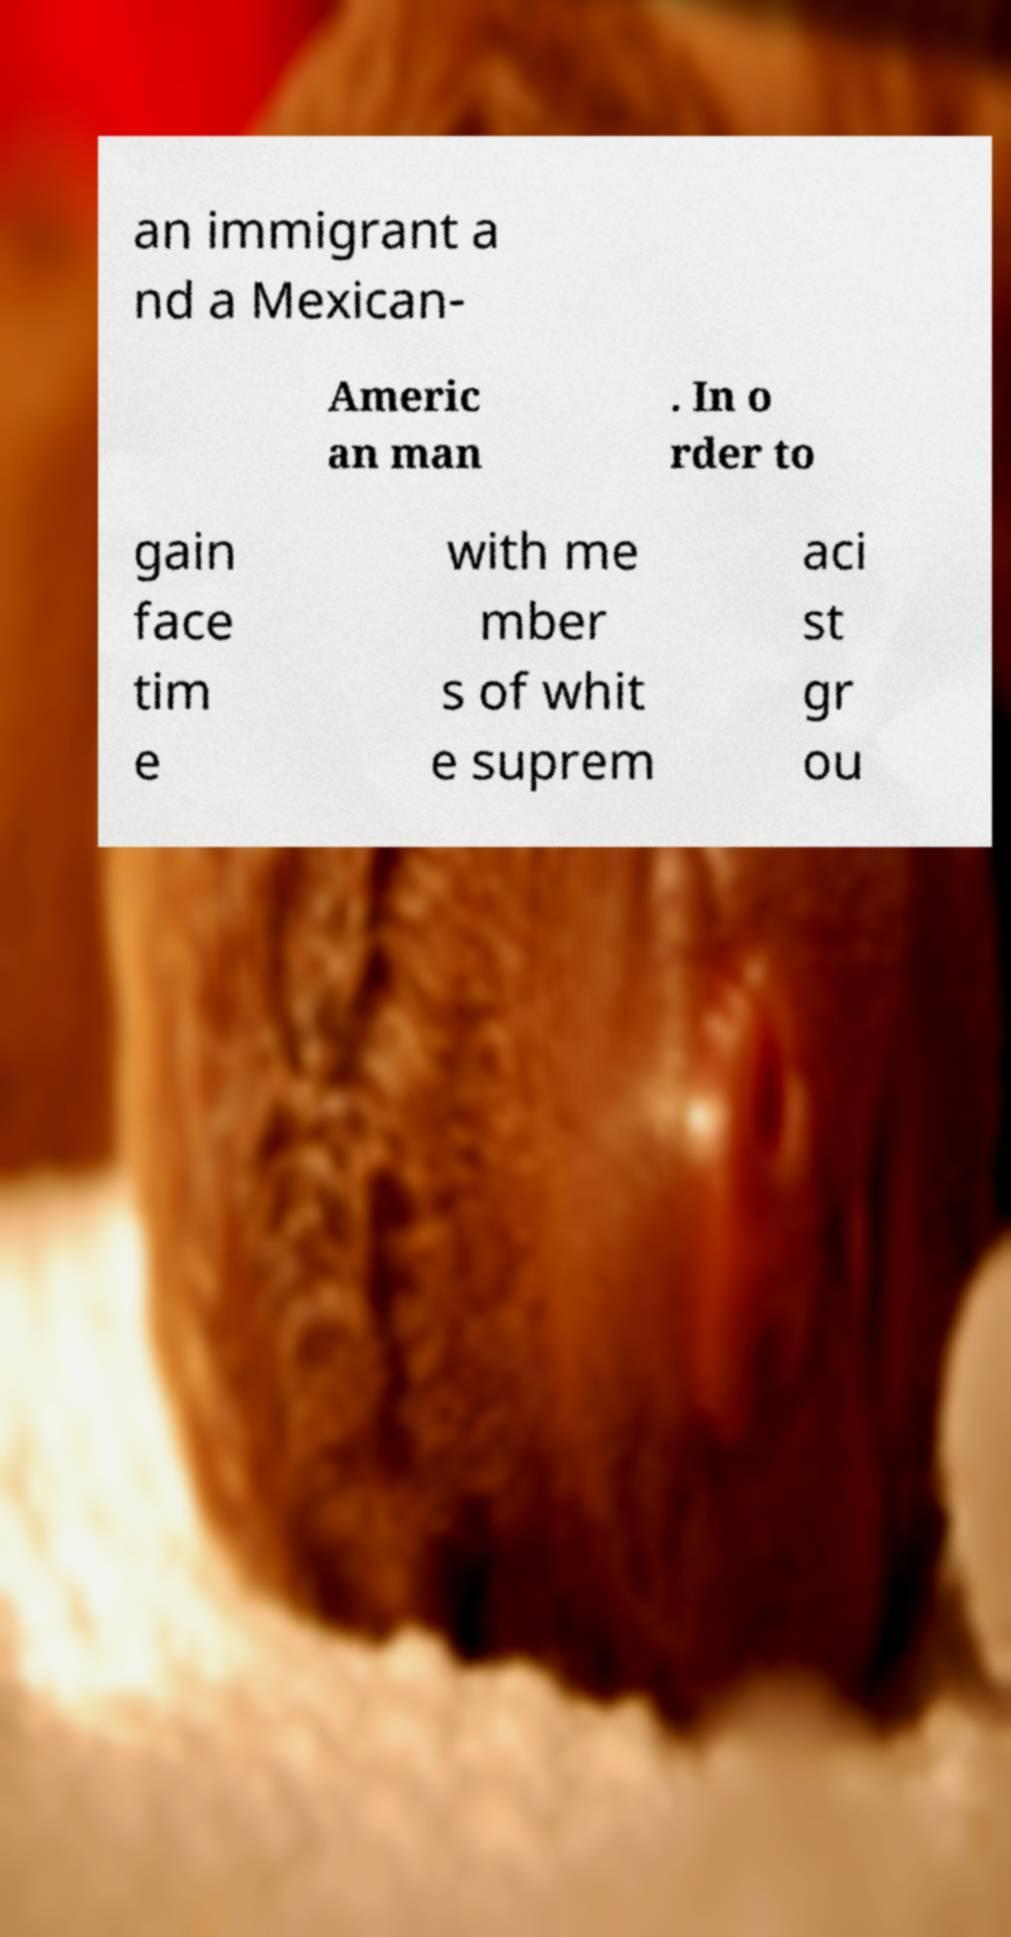Can you read and provide the text displayed in the image?This photo seems to have some interesting text. Can you extract and type it out for me? an immigrant a nd a Mexican- Americ an man . In o rder to gain face tim e with me mber s of whit e suprem aci st gr ou 